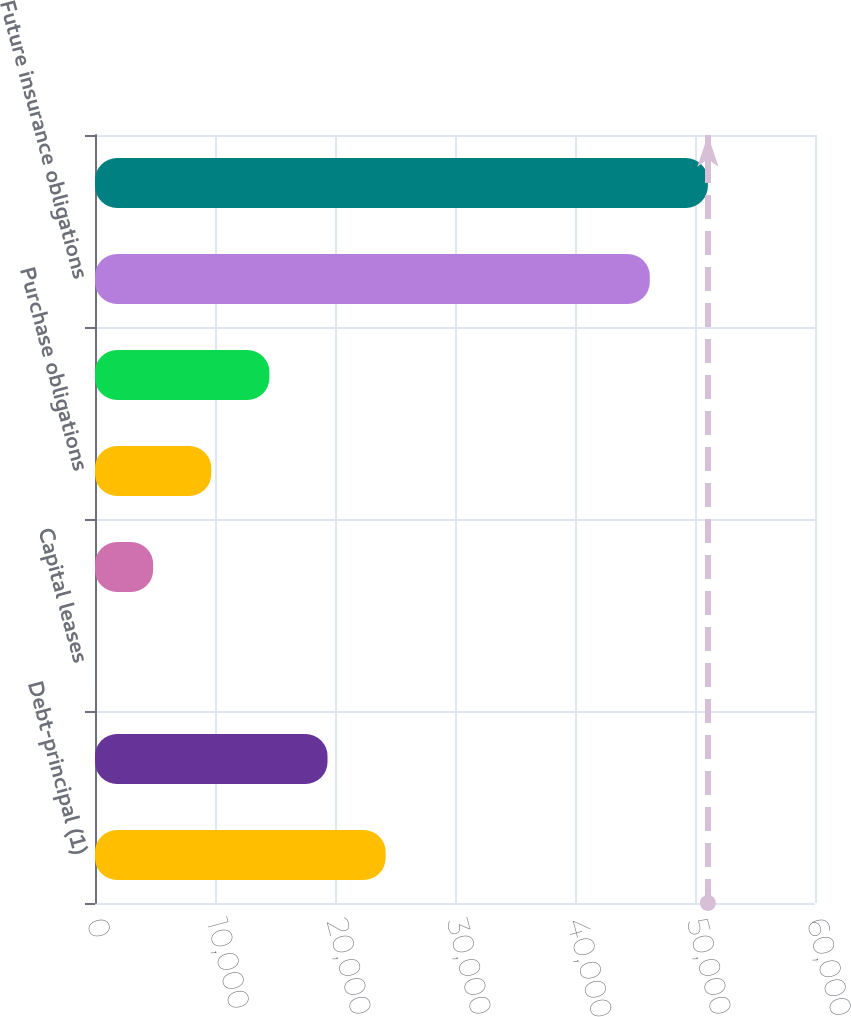<chart> <loc_0><loc_0><loc_500><loc_500><bar_chart><fcel>Debt-principal (1)<fcel>Debt-interest (2)<fcel>Capital leases<fcel>Operating leases<fcel>Purchase obligations<fcel>Pension obligations (3)<fcel>Future insurance obligations<fcel>Total<nl><fcel>24221.9<fcel>19377.8<fcel>1.72<fcel>4845.75<fcel>9689.78<fcel>14533.8<fcel>46232<fcel>51076<nl></chart> 